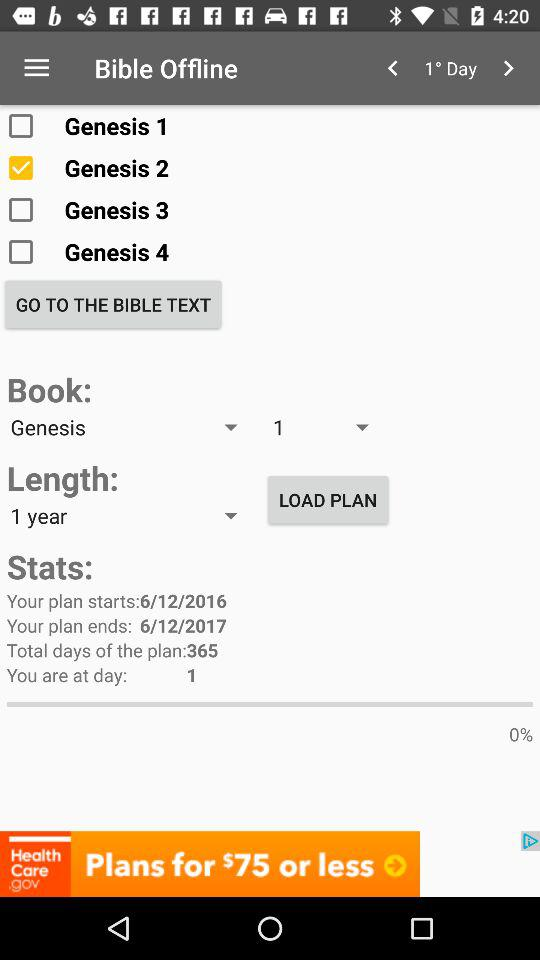How many days have you completed?
Answer the question using a single word or phrase. 1 